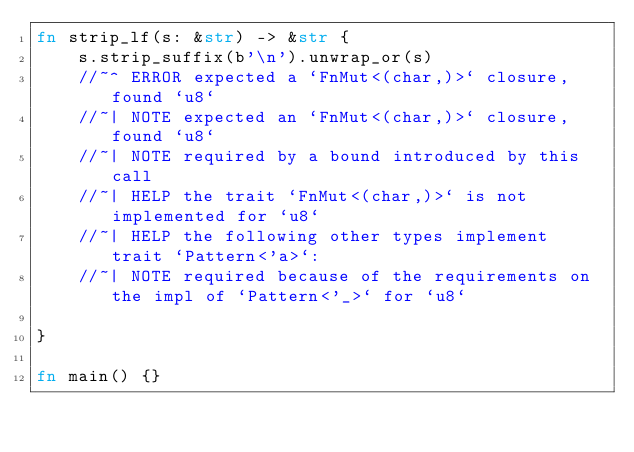Convert code to text. <code><loc_0><loc_0><loc_500><loc_500><_Rust_>fn strip_lf(s: &str) -> &str {
    s.strip_suffix(b'\n').unwrap_or(s)
    //~^ ERROR expected a `FnMut<(char,)>` closure, found `u8`
    //~| NOTE expected an `FnMut<(char,)>` closure, found `u8`
    //~| NOTE required by a bound introduced by this call
    //~| HELP the trait `FnMut<(char,)>` is not implemented for `u8`
    //~| HELP the following other types implement trait `Pattern<'a>`:
    //~| NOTE required because of the requirements on the impl of `Pattern<'_>` for `u8`

}

fn main() {}
</code> 